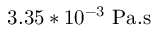Convert formula to latex. <formula><loc_0><loc_0><loc_500><loc_500>3 . 3 5 * 1 0 ^ { - 3 } P a . s</formula> 